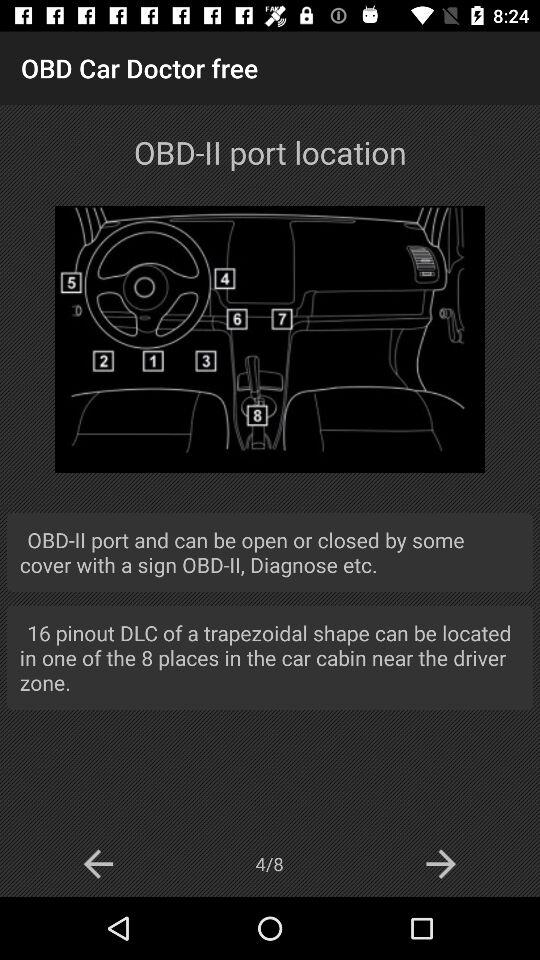How many pinouts are there in the trapezoidal-shaped DLC, which can be found in one of the eight locations? There are 16 pinouts in the trapezoidal-shaped DLC. 